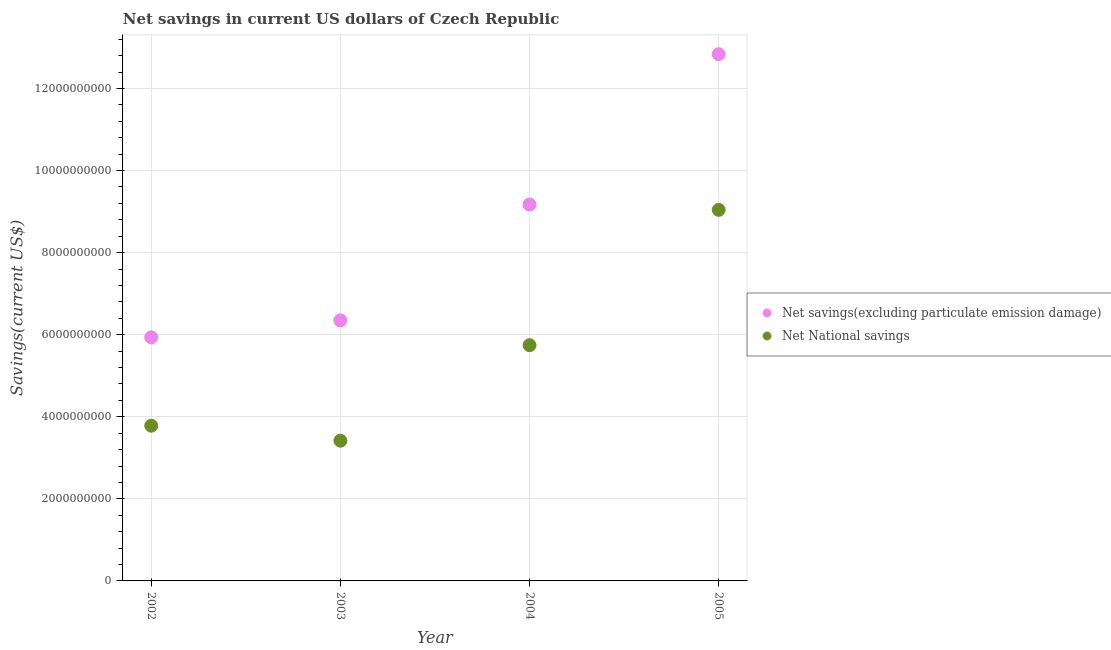Is the number of dotlines equal to the number of legend labels?
Your answer should be very brief. Yes. What is the net national savings in 2002?
Offer a very short reply. 3.78e+09. Across all years, what is the maximum net savings(excluding particulate emission damage)?
Give a very brief answer. 1.28e+1. Across all years, what is the minimum net national savings?
Ensure brevity in your answer.  3.42e+09. In which year was the net savings(excluding particulate emission damage) maximum?
Offer a terse response. 2005. In which year was the net savings(excluding particulate emission damage) minimum?
Offer a very short reply. 2002. What is the total net national savings in the graph?
Your response must be concise. 2.20e+1. What is the difference between the net savings(excluding particulate emission damage) in 2002 and that in 2004?
Ensure brevity in your answer.  -3.24e+09. What is the difference between the net savings(excluding particulate emission damage) in 2002 and the net national savings in 2004?
Provide a succinct answer. 1.91e+08. What is the average net national savings per year?
Your answer should be very brief. 5.50e+09. In the year 2004, what is the difference between the net national savings and net savings(excluding particulate emission damage)?
Ensure brevity in your answer.  -3.43e+09. In how many years, is the net savings(excluding particulate emission damage) greater than 11200000000 US$?
Make the answer very short. 1. What is the ratio of the net national savings in 2003 to that in 2005?
Make the answer very short. 0.38. Is the net savings(excluding particulate emission damage) in 2002 less than that in 2003?
Provide a short and direct response. Yes. Is the difference between the net national savings in 2002 and 2004 greater than the difference between the net savings(excluding particulate emission damage) in 2002 and 2004?
Make the answer very short. Yes. What is the difference between the highest and the second highest net national savings?
Ensure brevity in your answer.  3.30e+09. What is the difference between the highest and the lowest net national savings?
Provide a succinct answer. 5.63e+09. In how many years, is the net savings(excluding particulate emission damage) greater than the average net savings(excluding particulate emission damage) taken over all years?
Offer a very short reply. 2. Is the sum of the net national savings in 2003 and 2005 greater than the maximum net savings(excluding particulate emission damage) across all years?
Your response must be concise. No. Is the net national savings strictly greater than the net savings(excluding particulate emission damage) over the years?
Make the answer very short. No. What is the difference between two consecutive major ticks on the Y-axis?
Offer a very short reply. 2.00e+09. Are the values on the major ticks of Y-axis written in scientific E-notation?
Provide a succinct answer. No. Does the graph contain any zero values?
Make the answer very short. No. Does the graph contain grids?
Keep it short and to the point. Yes. Where does the legend appear in the graph?
Keep it short and to the point. Center right. What is the title of the graph?
Offer a very short reply. Net savings in current US dollars of Czech Republic. Does "Ages 15-24" appear as one of the legend labels in the graph?
Offer a very short reply. No. What is the label or title of the Y-axis?
Provide a succinct answer. Savings(current US$). What is the Savings(current US$) of Net savings(excluding particulate emission damage) in 2002?
Your response must be concise. 5.94e+09. What is the Savings(current US$) of Net National savings in 2002?
Your answer should be compact. 3.78e+09. What is the Savings(current US$) of Net savings(excluding particulate emission damage) in 2003?
Provide a succinct answer. 6.35e+09. What is the Savings(current US$) in Net National savings in 2003?
Give a very brief answer. 3.42e+09. What is the Savings(current US$) of Net savings(excluding particulate emission damage) in 2004?
Make the answer very short. 9.17e+09. What is the Savings(current US$) of Net National savings in 2004?
Keep it short and to the point. 5.74e+09. What is the Savings(current US$) in Net savings(excluding particulate emission damage) in 2005?
Your answer should be very brief. 1.28e+1. What is the Savings(current US$) in Net National savings in 2005?
Provide a short and direct response. 9.04e+09. Across all years, what is the maximum Savings(current US$) of Net savings(excluding particulate emission damage)?
Make the answer very short. 1.28e+1. Across all years, what is the maximum Savings(current US$) of Net National savings?
Your answer should be very brief. 9.04e+09. Across all years, what is the minimum Savings(current US$) in Net savings(excluding particulate emission damage)?
Make the answer very short. 5.94e+09. Across all years, what is the minimum Savings(current US$) in Net National savings?
Offer a terse response. 3.42e+09. What is the total Savings(current US$) of Net savings(excluding particulate emission damage) in the graph?
Provide a short and direct response. 3.43e+1. What is the total Savings(current US$) of Net National savings in the graph?
Provide a short and direct response. 2.20e+1. What is the difference between the Savings(current US$) of Net savings(excluding particulate emission damage) in 2002 and that in 2003?
Make the answer very short. -4.13e+08. What is the difference between the Savings(current US$) of Net National savings in 2002 and that in 2003?
Offer a very short reply. 3.66e+08. What is the difference between the Savings(current US$) of Net savings(excluding particulate emission damage) in 2002 and that in 2004?
Your response must be concise. -3.24e+09. What is the difference between the Savings(current US$) of Net National savings in 2002 and that in 2004?
Offer a very short reply. -1.96e+09. What is the difference between the Savings(current US$) of Net savings(excluding particulate emission damage) in 2002 and that in 2005?
Keep it short and to the point. -6.90e+09. What is the difference between the Savings(current US$) of Net National savings in 2002 and that in 2005?
Provide a short and direct response. -5.26e+09. What is the difference between the Savings(current US$) of Net savings(excluding particulate emission damage) in 2003 and that in 2004?
Your response must be concise. -2.82e+09. What is the difference between the Savings(current US$) of Net National savings in 2003 and that in 2004?
Offer a terse response. -2.33e+09. What is the difference between the Savings(current US$) in Net savings(excluding particulate emission damage) in 2003 and that in 2005?
Offer a very short reply. -6.49e+09. What is the difference between the Savings(current US$) of Net National savings in 2003 and that in 2005?
Provide a short and direct response. -5.63e+09. What is the difference between the Savings(current US$) of Net savings(excluding particulate emission damage) in 2004 and that in 2005?
Your response must be concise. -3.66e+09. What is the difference between the Savings(current US$) of Net National savings in 2004 and that in 2005?
Offer a very short reply. -3.30e+09. What is the difference between the Savings(current US$) of Net savings(excluding particulate emission damage) in 2002 and the Savings(current US$) of Net National savings in 2003?
Ensure brevity in your answer.  2.52e+09. What is the difference between the Savings(current US$) in Net savings(excluding particulate emission damage) in 2002 and the Savings(current US$) in Net National savings in 2004?
Make the answer very short. 1.91e+08. What is the difference between the Savings(current US$) of Net savings(excluding particulate emission damage) in 2002 and the Savings(current US$) of Net National savings in 2005?
Keep it short and to the point. -3.11e+09. What is the difference between the Savings(current US$) in Net savings(excluding particulate emission damage) in 2003 and the Savings(current US$) in Net National savings in 2004?
Offer a very short reply. 6.04e+08. What is the difference between the Savings(current US$) in Net savings(excluding particulate emission damage) in 2003 and the Savings(current US$) in Net National savings in 2005?
Provide a short and direct response. -2.69e+09. What is the difference between the Savings(current US$) in Net savings(excluding particulate emission damage) in 2004 and the Savings(current US$) in Net National savings in 2005?
Your answer should be very brief. 1.29e+08. What is the average Savings(current US$) in Net savings(excluding particulate emission damage) per year?
Provide a short and direct response. 8.57e+09. What is the average Savings(current US$) in Net National savings per year?
Your answer should be compact. 5.50e+09. In the year 2002, what is the difference between the Savings(current US$) in Net savings(excluding particulate emission damage) and Savings(current US$) in Net National savings?
Give a very brief answer. 2.15e+09. In the year 2003, what is the difference between the Savings(current US$) of Net savings(excluding particulate emission damage) and Savings(current US$) of Net National savings?
Ensure brevity in your answer.  2.93e+09. In the year 2004, what is the difference between the Savings(current US$) in Net savings(excluding particulate emission damage) and Savings(current US$) in Net National savings?
Your response must be concise. 3.43e+09. In the year 2005, what is the difference between the Savings(current US$) of Net savings(excluding particulate emission damage) and Savings(current US$) of Net National savings?
Provide a succinct answer. 3.79e+09. What is the ratio of the Savings(current US$) in Net savings(excluding particulate emission damage) in 2002 to that in 2003?
Offer a terse response. 0.93. What is the ratio of the Savings(current US$) of Net National savings in 2002 to that in 2003?
Your answer should be compact. 1.11. What is the ratio of the Savings(current US$) of Net savings(excluding particulate emission damage) in 2002 to that in 2004?
Offer a very short reply. 0.65. What is the ratio of the Savings(current US$) in Net National savings in 2002 to that in 2004?
Your response must be concise. 0.66. What is the ratio of the Savings(current US$) of Net savings(excluding particulate emission damage) in 2002 to that in 2005?
Your answer should be very brief. 0.46. What is the ratio of the Savings(current US$) in Net National savings in 2002 to that in 2005?
Provide a succinct answer. 0.42. What is the ratio of the Savings(current US$) in Net savings(excluding particulate emission damage) in 2003 to that in 2004?
Your answer should be compact. 0.69. What is the ratio of the Savings(current US$) in Net National savings in 2003 to that in 2004?
Provide a succinct answer. 0.59. What is the ratio of the Savings(current US$) in Net savings(excluding particulate emission damage) in 2003 to that in 2005?
Your response must be concise. 0.49. What is the ratio of the Savings(current US$) of Net National savings in 2003 to that in 2005?
Ensure brevity in your answer.  0.38. What is the ratio of the Savings(current US$) in Net savings(excluding particulate emission damage) in 2004 to that in 2005?
Make the answer very short. 0.71. What is the ratio of the Savings(current US$) in Net National savings in 2004 to that in 2005?
Offer a very short reply. 0.64. What is the difference between the highest and the second highest Savings(current US$) in Net savings(excluding particulate emission damage)?
Make the answer very short. 3.66e+09. What is the difference between the highest and the second highest Savings(current US$) in Net National savings?
Provide a succinct answer. 3.30e+09. What is the difference between the highest and the lowest Savings(current US$) in Net savings(excluding particulate emission damage)?
Provide a succinct answer. 6.90e+09. What is the difference between the highest and the lowest Savings(current US$) in Net National savings?
Provide a short and direct response. 5.63e+09. 